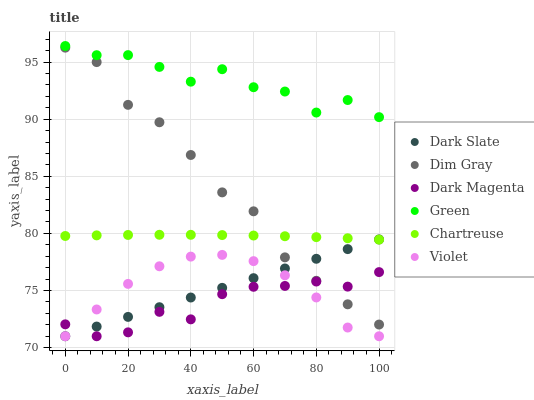Does Dark Magenta have the minimum area under the curve?
Answer yes or no. Yes. Does Green have the maximum area under the curve?
Answer yes or no. Yes. Does Dark Slate have the minimum area under the curve?
Answer yes or no. No. Does Dark Slate have the maximum area under the curve?
Answer yes or no. No. Is Dark Slate the smoothest?
Answer yes or no. Yes. Is Green the roughest?
Answer yes or no. Yes. Is Dark Magenta the smoothest?
Answer yes or no. No. Is Dark Magenta the roughest?
Answer yes or no. No. Does Dark Magenta have the lowest value?
Answer yes or no. Yes. Does Chartreuse have the lowest value?
Answer yes or no. No. Does Green have the highest value?
Answer yes or no. Yes. Does Dark Slate have the highest value?
Answer yes or no. No. Is Violet less than Dim Gray?
Answer yes or no. Yes. Is Green greater than Dim Gray?
Answer yes or no. Yes. Does Dim Gray intersect Dark Magenta?
Answer yes or no. Yes. Is Dim Gray less than Dark Magenta?
Answer yes or no. No. Is Dim Gray greater than Dark Magenta?
Answer yes or no. No. Does Violet intersect Dim Gray?
Answer yes or no. No. 